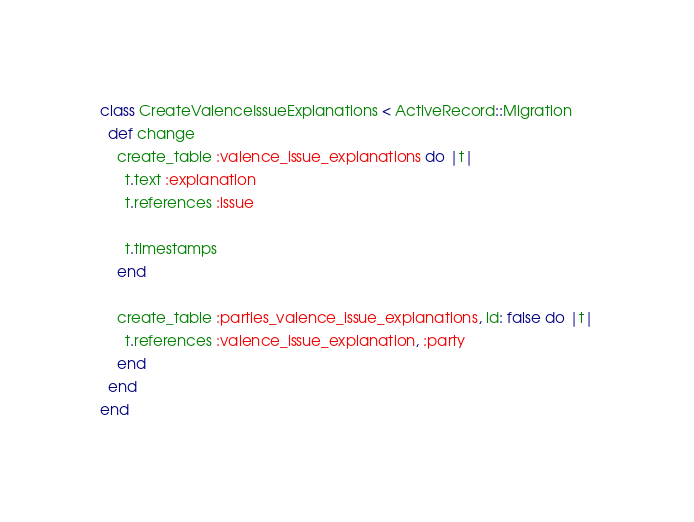Convert code to text. <code><loc_0><loc_0><loc_500><loc_500><_Ruby_>class CreateValenceIssueExplanations < ActiveRecord::Migration
  def change
    create_table :valence_issue_explanations do |t|
      t.text :explanation
      t.references :issue

      t.timestamps
    end

    create_table :parties_valence_issue_explanations, id: false do |t|
      t.references :valence_issue_explanation, :party
    end
  end
end
</code> 